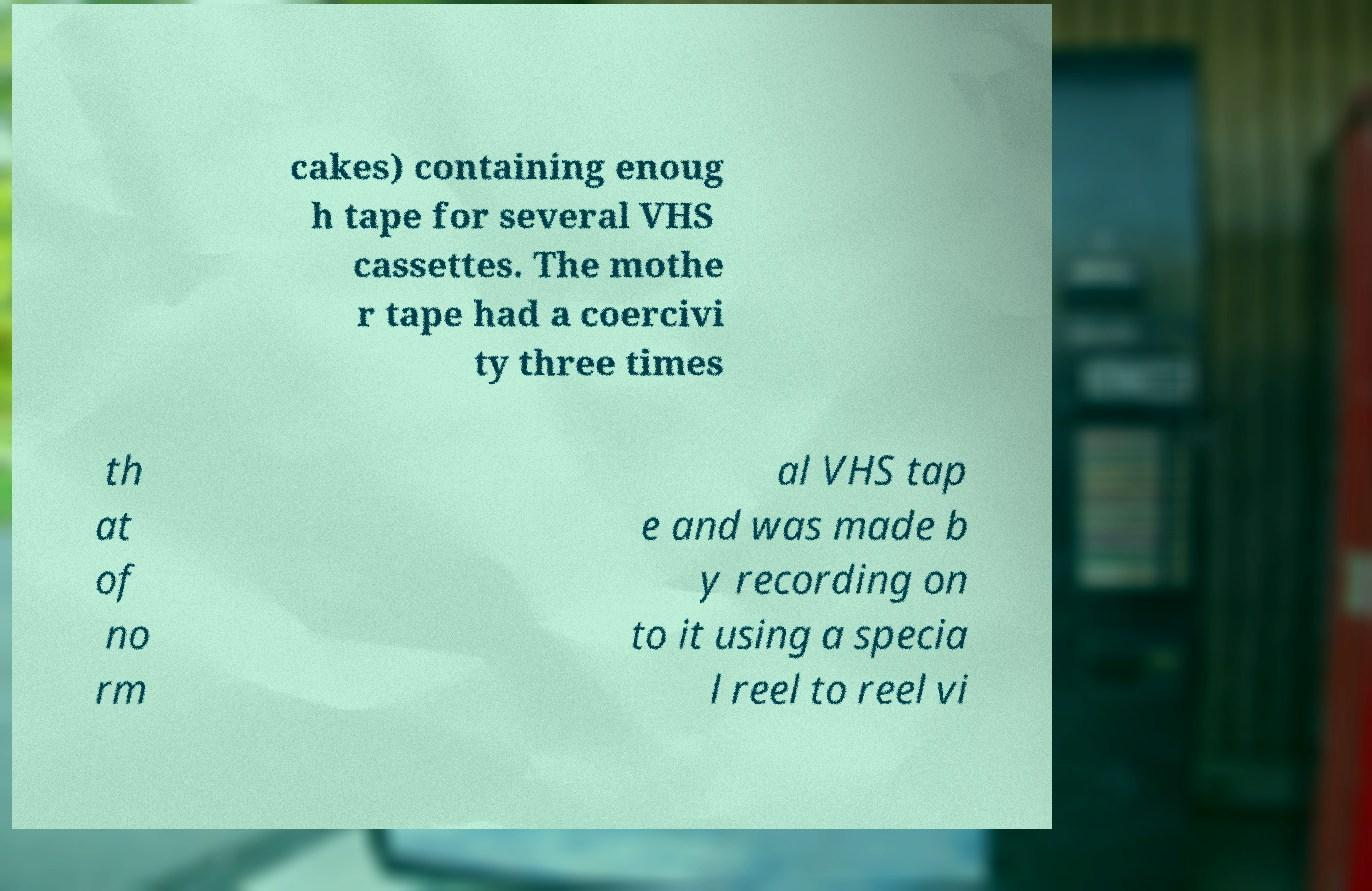For documentation purposes, I need the text within this image transcribed. Could you provide that? cakes) containing enoug h tape for several VHS cassettes. The mothe r tape had a coercivi ty three times th at of no rm al VHS tap e and was made b y recording on to it using a specia l reel to reel vi 